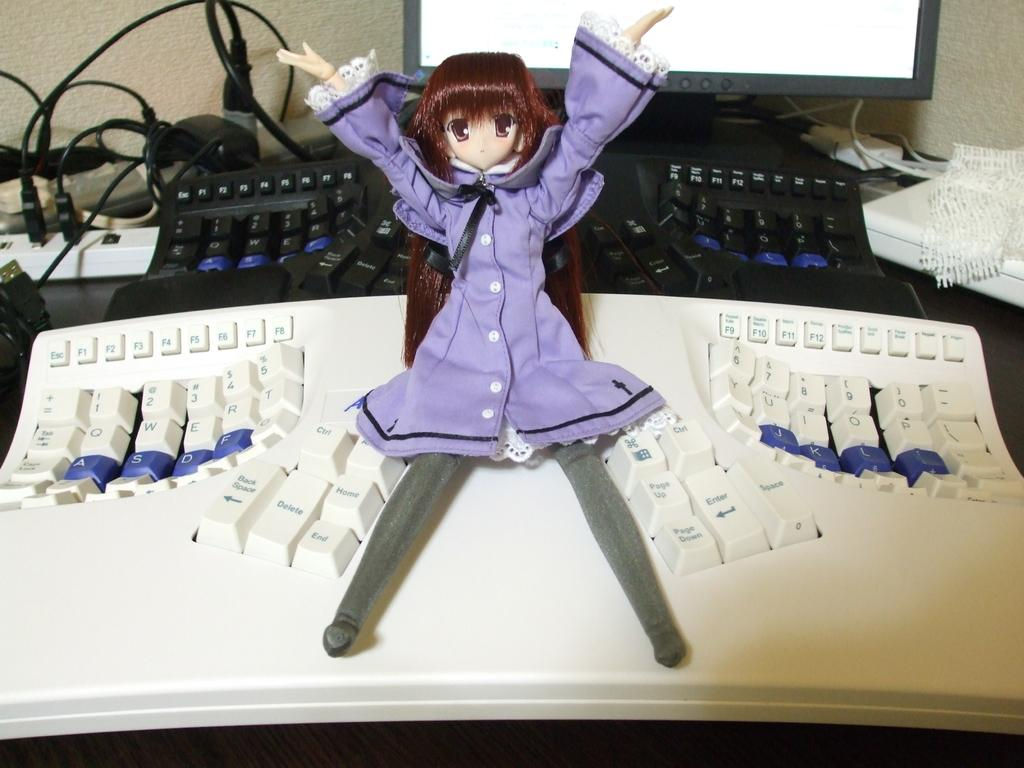What is placed on top of the keyboard in the image? There is a toy on a keyboard in the image. What is the keyboard placed on? The keyboard is on a platform. Are there any other keyboards visible in the image? Yes, there is another keyboard on the platform. What else can be seen on the platform? Cables, a connect box, a monitor, and an object are present on the platform. What is the background of the image? There is a wall in the image. How many knots are tied in the cables on the platform? There is no mention of knots in the cables in the image; the cables are simply present on the platform. What key does your uncle use to unlock the door in the image? There is no mention of a door, a lock, or your uncle in the image. 